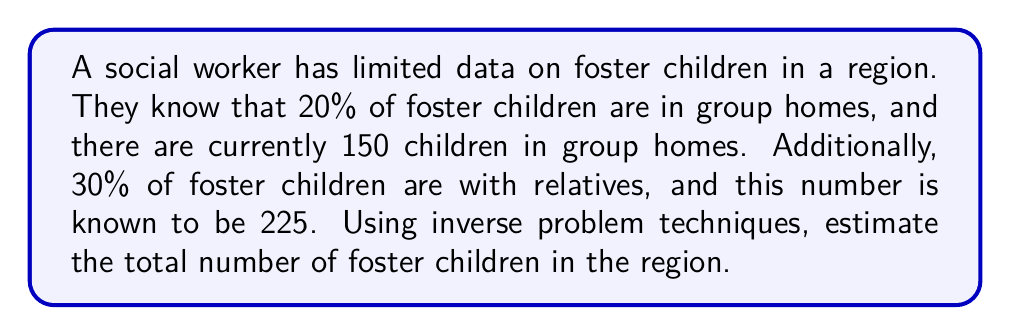Can you solve this math problem? Let's approach this step-by-step using inverse problem techniques:

1) Let $x$ be the total number of foster children in the region.

2) We have two pieces of information:
   a) 20% of $x$ are in group homes, which is 150 children.
   b) 30% of $x$ are with relatives, which is 225 children.

3) We can set up two equations:
   $$0.20x = 150$$ (Equation 1)
   $$0.30x = 225$$ (Equation 2)

4) To solve this inverse problem, we'll use a least squares approach. We want to minimize the sum of the squared differences between our model predictions and the observed data.

5) Let's define our objective function:
   $$f(x) = (0.20x - 150)^2 + (0.30x - 225)^2$$

6) To minimize this function, we take its derivative and set it to zero:
   $$f'(x) = 2(0.20x - 150)(0.20) + 2(0.30x - 225)(0.30) = 0$$

7) Simplifying:
   $$0.08(x - 750) + 0.18(x - 750) = 0$$
   $$0.26(x - 750) = 0$$

8) Solving for $x$:
   $$x = 750$$

9) We can verify this solution satisfies both original equations:
   $$0.20(750) = 150$$
   $$0.30(750) = 225$$

Therefore, our best estimate for the total number of foster children in the region is 750.
Answer: 750 foster children 